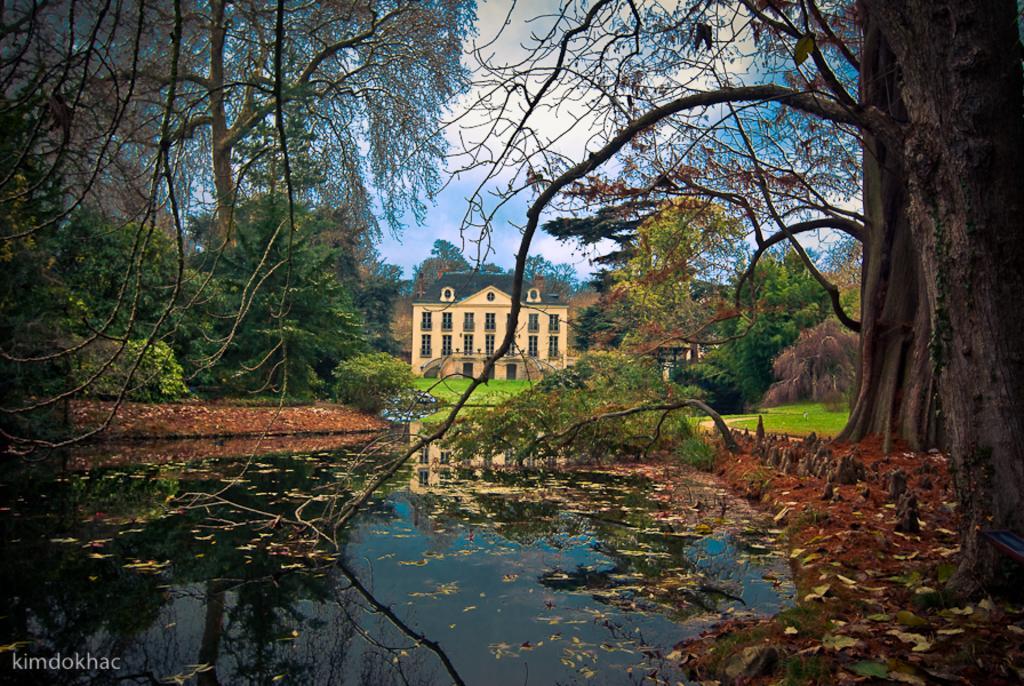How would you summarize this image in a sentence or two? In this image we can see a house, trees, plants, grass and sky. 